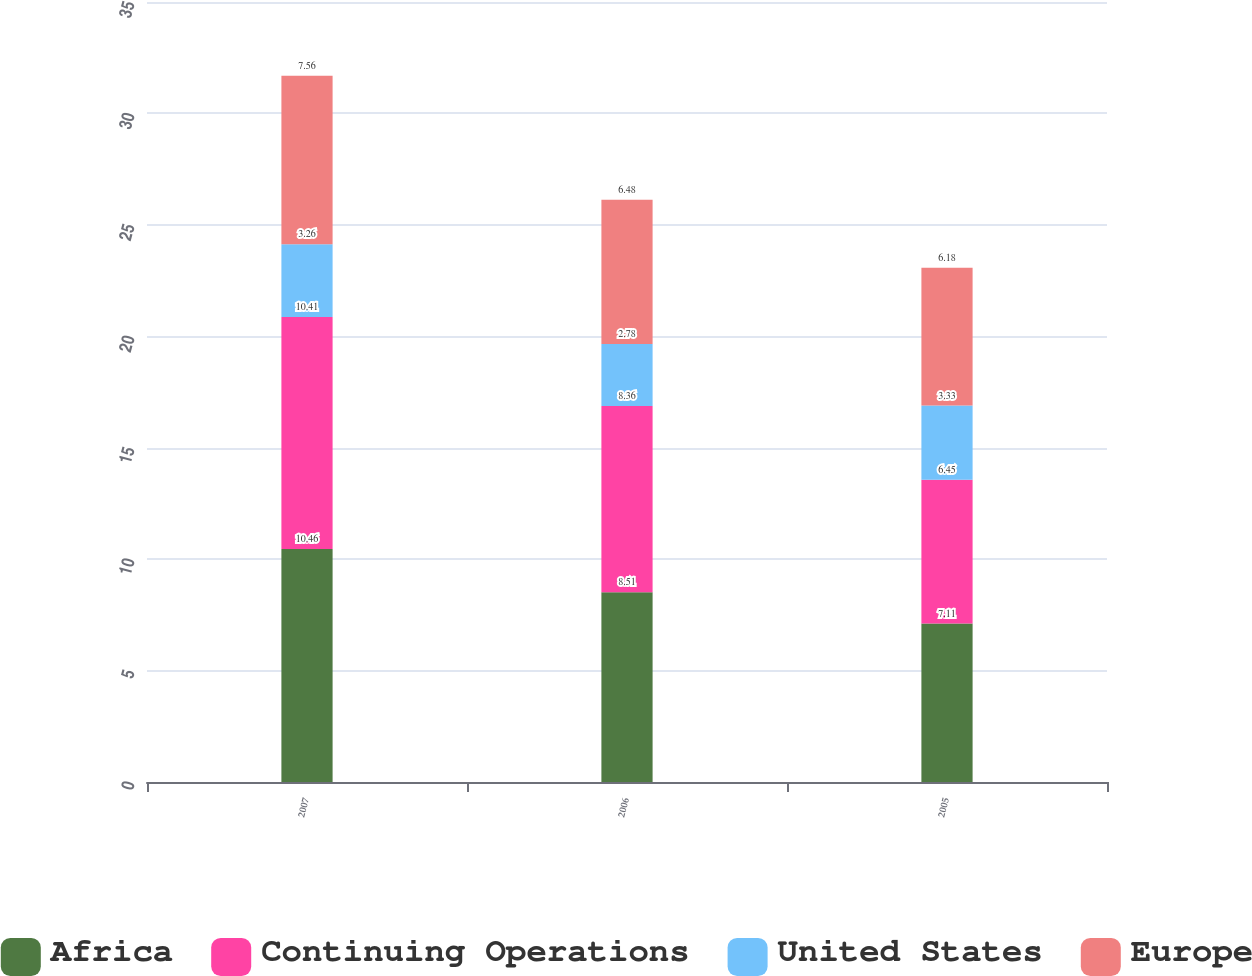<chart> <loc_0><loc_0><loc_500><loc_500><stacked_bar_chart><ecel><fcel>2007<fcel>2006<fcel>2005<nl><fcel>Africa<fcel>10.46<fcel>8.51<fcel>7.11<nl><fcel>Continuing Operations<fcel>10.41<fcel>8.36<fcel>6.45<nl><fcel>United States<fcel>3.26<fcel>2.78<fcel>3.33<nl><fcel>Europe<fcel>7.56<fcel>6.48<fcel>6.18<nl></chart> 